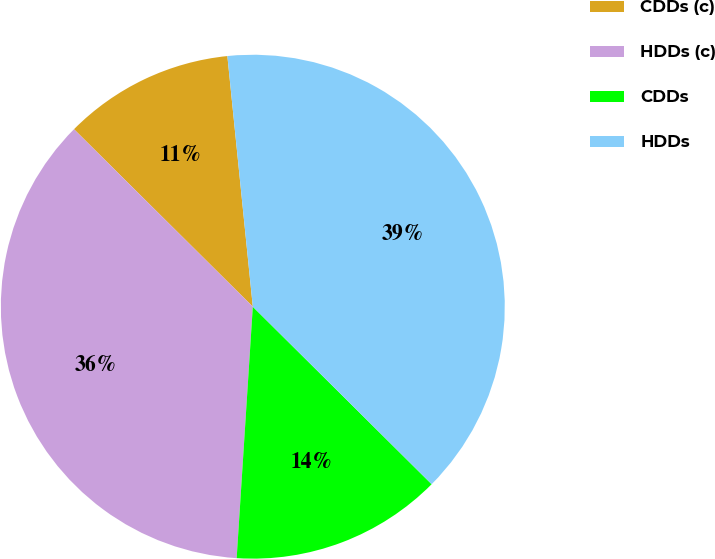Convert chart. <chart><loc_0><loc_0><loc_500><loc_500><pie_chart><fcel>CDDs (c)<fcel>HDDs (c)<fcel>CDDs<fcel>HDDs<nl><fcel>10.95%<fcel>36.42%<fcel>13.58%<fcel>39.05%<nl></chart> 